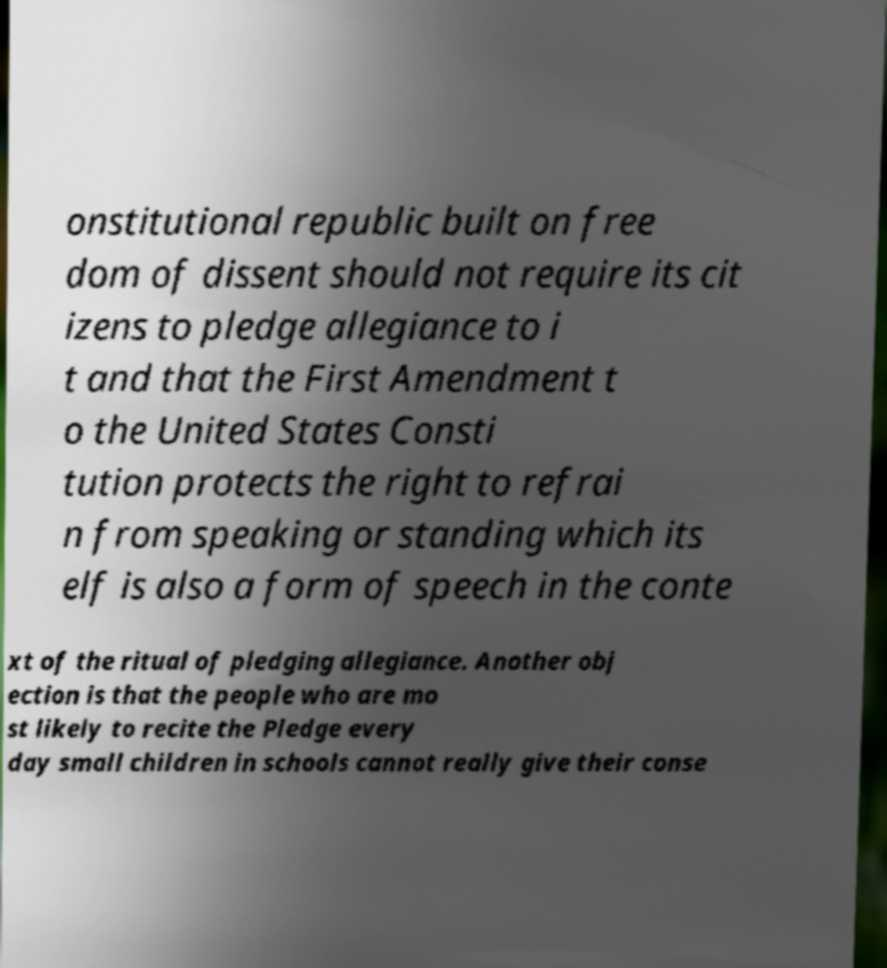Could you extract and type out the text from this image? onstitutional republic built on free dom of dissent should not require its cit izens to pledge allegiance to i t and that the First Amendment t o the United States Consti tution protects the right to refrai n from speaking or standing which its elf is also a form of speech in the conte xt of the ritual of pledging allegiance. Another obj ection is that the people who are mo st likely to recite the Pledge every day small children in schools cannot really give their conse 